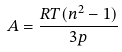Convert formula to latex. <formula><loc_0><loc_0><loc_500><loc_500>A = \frac { R T ( n ^ { 2 } - 1 ) } { 3 p }</formula> 